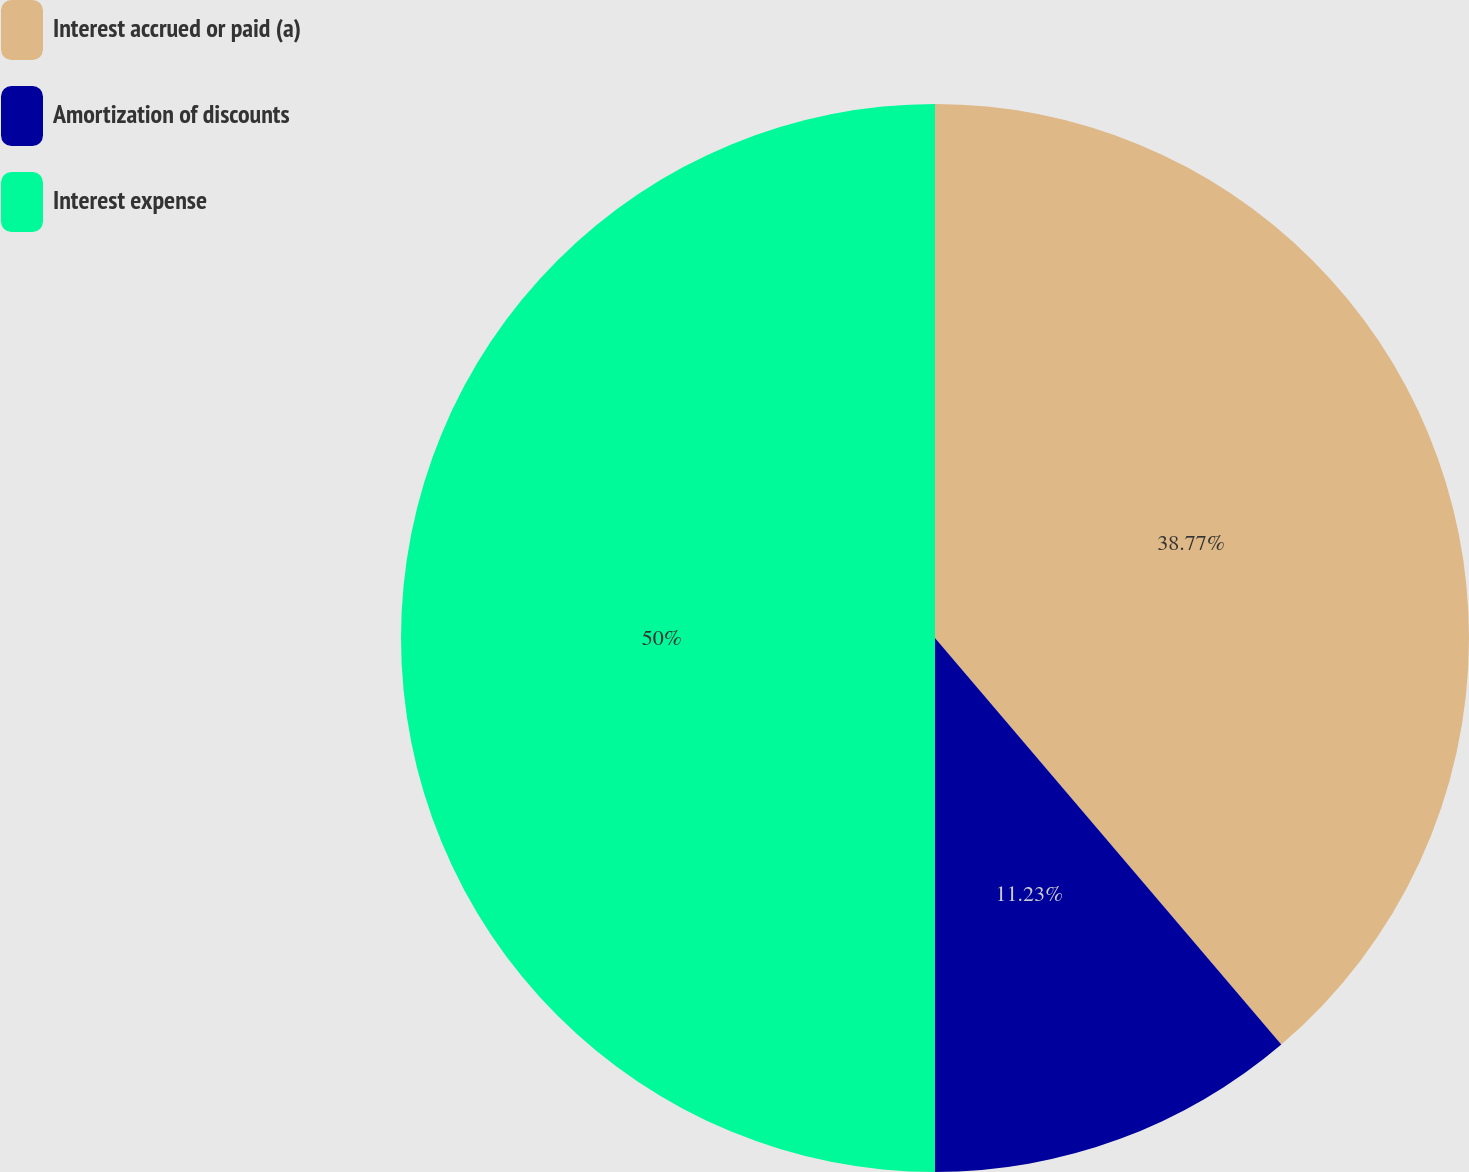<chart> <loc_0><loc_0><loc_500><loc_500><pie_chart><fcel>Interest accrued or paid (a)<fcel>Amortization of discounts<fcel>Interest expense<nl><fcel>38.77%<fcel>11.23%<fcel>50.0%<nl></chart> 